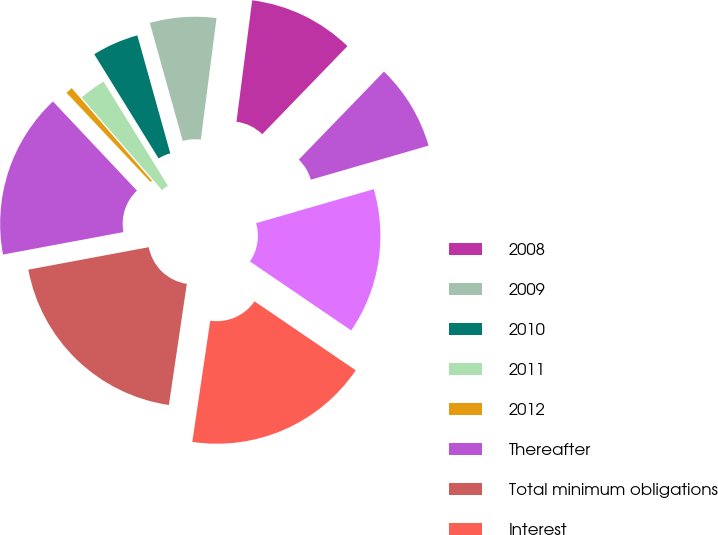<chart> <loc_0><loc_0><loc_500><loc_500><pie_chart><fcel>2008<fcel>2009<fcel>2010<fcel>2011<fcel>2012<fcel>Thereafter<fcel>Total minimum obligations<fcel>Interest<fcel>Present value of minimum<fcel>Current portion<nl><fcel>10.19%<fcel>6.38%<fcel>4.47%<fcel>2.56%<fcel>0.66%<fcel>15.91%<fcel>19.72%<fcel>17.82%<fcel>14.0%<fcel>8.28%<nl></chart> 